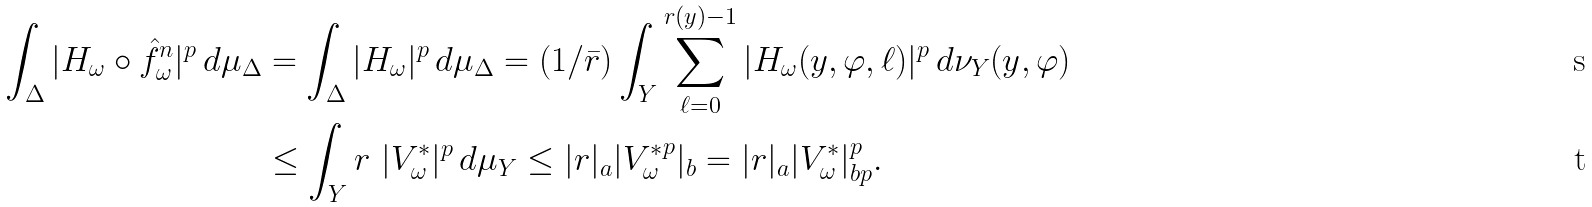<formula> <loc_0><loc_0><loc_500><loc_500>\int _ { \Delta } | H _ { \omega } \circ \hat { f } _ { \omega } ^ { n } | ^ { p } \, d \mu _ { \Delta } & = \int _ { \Delta } | H _ { \omega } | ^ { p } \, d \mu _ { \Delta } = ( 1 / \bar { r } ) \int _ { Y } \sum _ { \ell = 0 } ^ { r ( y ) - 1 } | H _ { \omega } ( y , \varphi , \ell ) | ^ { p } \, d \nu _ { Y } ( y , \varphi ) \\ & \leq \int _ { Y } r \ | V ^ { * } _ { \omega } | ^ { p } \, d \mu _ { Y } \leq | r | _ { a } | { V ^ { * } _ { \omega } } ^ { p } | _ { b } = | r | _ { a } | V ^ { * } _ { \omega } | _ { b p } ^ { p } .</formula> 